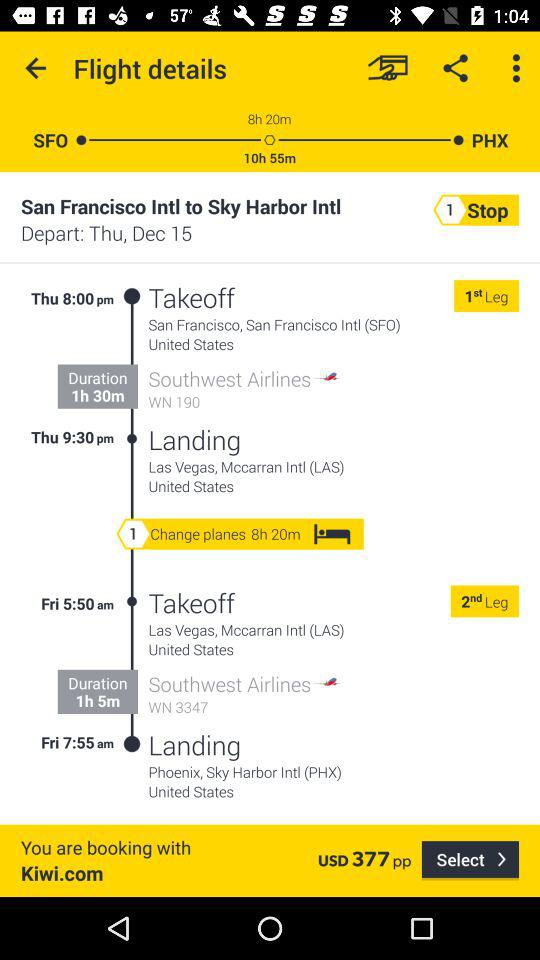What is the price of the flight ticket? The price of the flight ticket is 377 USD. 